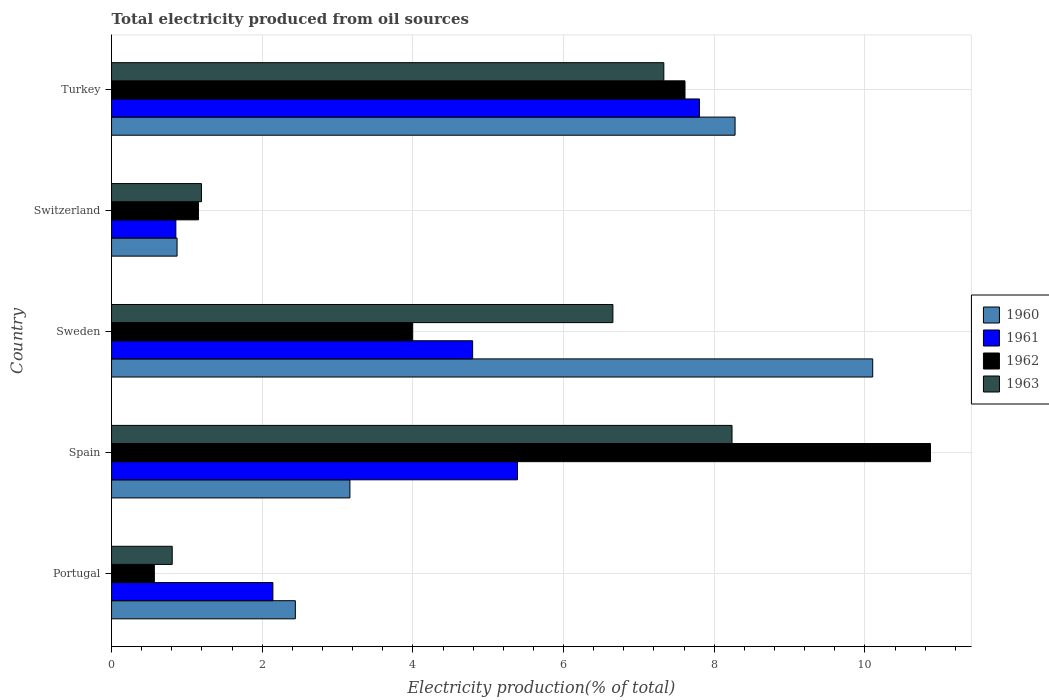How many different coloured bars are there?
Offer a very short reply. 4. Are the number of bars per tick equal to the number of legend labels?
Ensure brevity in your answer.  Yes. Are the number of bars on each tick of the Y-axis equal?
Provide a succinct answer. Yes. What is the label of the 2nd group of bars from the top?
Your response must be concise. Switzerland. In how many cases, is the number of bars for a given country not equal to the number of legend labels?
Provide a succinct answer. 0. What is the total electricity produced in 1961 in Spain?
Keep it short and to the point. 5.39. Across all countries, what is the maximum total electricity produced in 1963?
Your answer should be compact. 8.24. Across all countries, what is the minimum total electricity produced in 1960?
Make the answer very short. 0.87. What is the total total electricity produced in 1961 in the graph?
Your response must be concise. 20.98. What is the difference between the total electricity produced in 1962 in Portugal and that in Spain?
Your answer should be compact. -10.3. What is the difference between the total electricity produced in 1960 in Sweden and the total electricity produced in 1963 in Spain?
Give a very brief answer. 1.87. What is the average total electricity produced in 1962 per country?
Give a very brief answer. 4.84. What is the difference between the total electricity produced in 1963 and total electricity produced in 1960 in Turkey?
Keep it short and to the point. -0.95. What is the ratio of the total electricity produced in 1960 in Spain to that in Turkey?
Provide a succinct answer. 0.38. Is the total electricity produced in 1961 in Portugal less than that in Switzerland?
Make the answer very short. No. What is the difference between the highest and the second highest total electricity produced in 1961?
Your answer should be compact. 2.42. What is the difference between the highest and the lowest total electricity produced in 1961?
Your response must be concise. 6.95. In how many countries, is the total electricity produced in 1960 greater than the average total electricity produced in 1960 taken over all countries?
Your answer should be very brief. 2. What does the 2nd bar from the top in Portugal represents?
Your response must be concise. 1962. What does the 4th bar from the bottom in Portugal represents?
Make the answer very short. 1963. Are all the bars in the graph horizontal?
Ensure brevity in your answer.  Yes. Are the values on the major ticks of X-axis written in scientific E-notation?
Keep it short and to the point. No. Does the graph contain grids?
Offer a very short reply. Yes. What is the title of the graph?
Make the answer very short. Total electricity produced from oil sources. What is the label or title of the X-axis?
Keep it short and to the point. Electricity production(% of total). What is the label or title of the Y-axis?
Offer a terse response. Country. What is the Electricity production(% of total) in 1960 in Portugal?
Ensure brevity in your answer.  2.44. What is the Electricity production(% of total) of 1961 in Portugal?
Give a very brief answer. 2.14. What is the Electricity production(% of total) in 1962 in Portugal?
Your answer should be very brief. 0.57. What is the Electricity production(% of total) in 1963 in Portugal?
Make the answer very short. 0.81. What is the Electricity production(% of total) in 1960 in Spain?
Provide a succinct answer. 3.16. What is the Electricity production(% of total) in 1961 in Spain?
Your response must be concise. 5.39. What is the Electricity production(% of total) of 1962 in Spain?
Offer a terse response. 10.87. What is the Electricity production(% of total) in 1963 in Spain?
Your response must be concise. 8.24. What is the Electricity production(% of total) in 1960 in Sweden?
Keep it short and to the point. 10.1. What is the Electricity production(% of total) of 1961 in Sweden?
Offer a terse response. 4.79. What is the Electricity production(% of total) in 1962 in Sweden?
Provide a succinct answer. 4. What is the Electricity production(% of total) in 1963 in Sweden?
Your response must be concise. 6.66. What is the Electricity production(% of total) of 1960 in Switzerland?
Your response must be concise. 0.87. What is the Electricity production(% of total) of 1961 in Switzerland?
Offer a very short reply. 0.85. What is the Electricity production(% of total) in 1962 in Switzerland?
Make the answer very short. 1.15. What is the Electricity production(% of total) of 1963 in Switzerland?
Keep it short and to the point. 1.19. What is the Electricity production(% of total) in 1960 in Turkey?
Offer a very short reply. 8.28. What is the Electricity production(% of total) in 1961 in Turkey?
Provide a short and direct response. 7.8. What is the Electricity production(% of total) of 1962 in Turkey?
Offer a terse response. 7.61. What is the Electricity production(% of total) in 1963 in Turkey?
Your answer should be compact. 7.33. Across all countries, what is the maximum Electricity production(% of total) in 1960?
Offer a terse response. 10.1. Across all countries, what is the maximum Electricity production(% of total) in 1961?
Your answer should be very brief. 7.8. Across all countries, what is the maximum Electricity production(% of total) of 1962?
Offer a very short reply. 10.87. Across all countries, what is the maximum Electricity production(% of total) of 1963?
Ensure brevity in your answer.  8.24. Across all countries, what is the minimum Electricity production(% of total) in 1960?
Offer a terse response. 0.87. Across all countries, what is the minimum Electricity production(% of total) of 1961?
Keep it short and to the point. 0.85. Across all countries, what is the minimum Electricity production(% of total) of 1962?
Offer a very short reply. 0.57. Across all countries, what is the minimum Electricity production(% of total) in 1963?
Your answer should be compact. 0.81. What is the total Electricity production(% of total) of 1960 in the graph?
Your answer should be very brief. 24.85. What is the total Electricity production(% of total) in 1961 in the graph?
Make the answer very short. 20.98. What is the total Electricity production(% of total) of 1962 in the graph?
Ensure brevity in your answer.  24.2. What is the total Electricity production(% of total) of 1963 in the graph?
Offer a terse response. 24.22. What is the difference between the Electricity production(% of total) in 1960 in Portugal and that in Spain?
Provide a succinct answer. -0.72. What is the difference between the Electricity production(% of total) in 1961 in Portugal and that in Spain?
Ensure brevity in your answer.  -3.25. What is the difference between the Electricity production(% of total) of 1962 in Portugal and that in Spain?
Provide a short and direct response. -10.3. What is the difference between the Electricity production(% of total) in 1963 in Portugal and that in Spain?
Provide a succinct answer. -7.43. What is the difference between the Electricity production(% of total) in 1960 in Portugal and that in Sweden?
Ensure brevity in your answer.  -7.66. What is the difference between the Electricity production(% of total) of 1961 in Portugal and that in Sweden?
Make the answer very short. -2.65. What is the difference between the Electricity production(% of total) in 1962 in Portugal and that in Sweden?
Your response must be concise. -3.43. What is the difference between the Electricity production(% of total) in 1963 in Portugal and that in Sweden?
Ensure brevity in your answer.  -5.85. What is the difference between the Electricity production(% of total) of 1960 in Portugal and that in Switzerland?
Your answer should be very brief. 1.57. What is the difference between the Electricity production(% of total) in 1961 in Portugal and that in Switzerland?
Your answer should be compact. 1.29. What is the difference between the Electricity production(% of total) of 1962 in Portugal and that in Switzerland?
Give a very brief answer. -0.59. What is the difference between the Electricity production(% of total) of 1963 in Portugal and that in Switzerland?
Keep it short and to the point. -0.39. What is the difference between the Electricity production(% of total) in 1960 in Portugal and that in Turkey?
Provide a succinct answer. -5.84. What is the difference between the Electricity production(% of total) in 1961 in Portugal and that in Turkey?
Keep it short and to the point. -5.66. What is the difference between the Electricity production(% of total) in 1962 in Portugal and that in Turkey?
Provide a short and direct response. -7.04. What is the difference between the Electricity production(% of total) in 1963 in Portugal and that in Turkey?
Offer a terse response. -6.53. What is the difference between the Electricity production(% of total) in 1960 in Spain and that in Sweden?
Your response must be concise. -6.94. What is the difference between the Electricity production(% of total) in 1961 in Spain and that in Sweden?
Ensure brevity in your answer.  0.6. What is the difference between the Electricity production(% of total) in 1962 in Spain and that in Sweden?
Give a very brief answer. 6.87. What is the difference between the Electricity production(% of total) of 1963 in Spain and that in Sweden?
Ensure brevity in your answer.  1.58. What is the difference between the Electricity production(% of total) of 1960 in Spain and that in Switzerland?
Offer a terse response. 2.29. What is the difference between the Electricity production(% of total) in 1961 in Spain and that in Switzerland?
Provide a succinct answer. 4.53. What is the difference between the Electricity production(% of total) in 1962 in Spain and that in Switzerland?
Your answer should be compact. 9.72. What is the difference between the Electricity production(% of total) in 1963 in Spain and that in Switzerland?
Give a very brief answer. 7.04. What is the difference between the Electricity production(% of total) of 1960 in Spain and that in Turkey?
Offer a terse response. -5.11. What is the difference between the Electricity production(% of total) of 1961 in Spain and that in Turkey?
Give a very brief answer. -2.42. What is the difference between the Electricity production(% of total) of 1962 in Spain and that in Turkey?
Give a very brief answer. 3.26. What is the difference between the Electricity production(% of total) of 1963 in Spain and that in Turkey?
Ensure brevity in your answer.  0.91. What is the difference between the Electricity production(% of total) of 1960 in Sweden and that in Switzerland?
Provide a succinct answer. 9.23. What is the difference between the Electricity production(% of total) of 1961 in Sweden and that in Switzerland?
Offer a very short reply. 3.94. What is the difference between the Electricity production(% of total) in 1962 in Sweden and that in Switzerland?
Your response must be concise. 2.84. What is the difference between the Electricity production(% of total) in 1963 in Sweden and that in Switzerland?
Your response must be concise. 5.46. What is the difference between the Electricity production(% of total) in 1960 in Sweden and that in Turkey?
Make the answer very short. 1.83. What is the difference between the Electricity production(% of total) in 1961 in Sweden and that in Turkey?
Ensure brevity in your answer.  -3.01. What is the difference between the Electricity production(% of total) in 1962 in Sweden and that in Turkey?
Offer a very short reply. -3.61. What is the difference between the Electricity production(% of total) in 1963 in Sweden and that in Turkey?
Keep it short and to the point. -0.68. What is the difference between the Electricity production(% of total) in 1960 in Switzerland and that in Turkey?
Offer a terse response. -7.41. What is the difference between the Electricity production(% of total) in 1961 in Switzerland and that in Turkey?
Offer a terse response. -6.95. What is the difference between the Electricity production(% of total) in 1962 in Switzerland and that in Turkey?
Ensure brevity in your answer.  -6.46. What is the difference between the Electricity production(% of total) in 1963 in Switzerland and that in Turkey?
Provide a succinct answer. -6.14. What is the difference between the Electricity production(% of total) in 1960 in Portugal and the Electricity production(% of total) in 1961 in Spain?
Provide a succinct answer. -2.95. What is the difference between the Electricity production(% of total) of 1960 in Portugal and the Electricity production(% of total) of 1962 in Spain?
Your answer should be very brief. -8.43. What is the difference between the Electricity production(% of total) in 1960 in Portugal and the Electricity production(% of total) in 1963 in Spain?
Provide a short and direct response. -5.8. What is the difference between the Electricity production(% of total) in 1961 in Portugal and the Electricity production(% of total) in 1962 in Spain?
Offer a very short reply. -8.73. What is the difference between the Electricity production(% of total) in 1961 in Portugal and the Electricity production(% of total) in 1963 in Spain?
Give a very brief answer. -6.09. What is the difference between the Electricity production(% of total) in 1962 in Portugal and the Electricity production(% of total) in 1963 in Spain?
Keep it short and to the point. -7.67. What is the difference between the Electricity production(% of total) in 1960 in Portugal and the Electricity production(% of total) in 1961 in Sweden?
Keep it short and to the point. -2.35. What is the difference between the Electricity production(% of total) of 1960 in Portugal and the Electricity production(% of total) of 1962 in Sweden?
Make the answer very short. -1.56. What is the difference between the Electricity production(% of total) in 1960 in Portugal and the Electricity production(% of total) in 1963 in Sweden?
Provide a short and direct response. -4.22. What is the difference between the Electricity production(% of total) of 1961 in Portugal and the Electricity production(% of total) of 1962 in Sweden?
Offer a very short reply. -1.86. What is the difference between the Electricity production(% of total) of 1961 in Portugal and the Electricity production(% of total) of 1963 in Sweden?
Offer a very short reply. -4.51. What is the difference between the Electricity production(% of total) in 1962 in Portugal and the Electricity production(% of total) in 1963 in Sweden?
Your response must be concise. -6.09. What is the difference between the Electricity production(% of total) in 1960 in Portugal and the Electricity production(% of total) in 1961 in Switzerland?
Make the answer very short. 1.59. What is the difference between the Electricity production(% of total) in 1960 in Portugal and the Electricity production(% of total) in 1962 in Switzerland?
Your answer should be compact. 1.29. What is the difference between the Electricity production(% of total) of 1960 in Portugal and the Electricity production(% of total) of 1963 in Switzerland?
Provide a short and direct response. 1.25. What is the difference between the Electricity production(% of total) in 1961 in Portugal and the Electricity production(% of total) in 1962 in Switzerland?
Make the answer very short. 0.99. What is the difference between the Electricity production(% of total) in 1961 in Portugal and the Electricity production(% of total) in 1963 in Switzerland?
Ensure brevity in your answer.  0.95. What is the difference between the Electricity production(% of total) in 1962 in Portugal and the Electricity production(% of total) in 1963 in Switzerland?
Your response must be concise. -0.63. What is the difference between the Electricity production(% of total) in 1960 in Portugal and the Electricity production(% of total) in 1961 in Turkey?
Keep it short and to the point. -5.36. What is the difference between the Electricity production(% of total) of 1960 in Portugal and the Electricity production(% of total) of 1962 in Turkey?
Offer a terse response. -5.17. What is the difference between the Electricity production(% of total) in 1960 in Portugal and the Electricity production(% of total) in 1963 in Turkey?
Ensure brevity in your answer.  -4.89. What is the difference between the Electricity production(% of total) in 1961 in Portugal and the Electricity production(% of total) in 1962 in Turkey?
Offer a terse response. -5.47. What is the difference between the Electricity production(% of total) in 1961 in Portugal and the Electricity production(% of total) in 1963 in Turkey?
Make the answer very short. -5.19. What is the difference between the Electricity production(% of total) in 1962 in Portugal and the Electricity production(% of total) in 1963 in Turkey?
Ensure brevity in your answer.  -6.76. What is the difference between the Electricity production(% of total) of 1960 in Spain and the Electricity production(% of total) of 1961 in Sweden?
Give a very brief answer. -1.63. What is the difference between the Electricity production(% of total) of 1960 in Spain and the Electricity production(% of total) of 1963 in Sweden?
Provide a short and direct response. -3.49. What is the difference between the Electricity production(% of total) of 1961 in Spain and the Electricity production(% of total) of 1962 in Sweden?
Ensure brevity in your answer.  1.39. What is the difference between the Electricity production(% of total) of 1961 in Spain and the Electricity production(% of total) of 1963 in Sweden?
Your answer should be compact. -1.27. What is the difference between the Electricity production(% of total) in 1962 in Spain and the Electricity production(% of total) in 1963 in Sweden?
Provide a short and direct response. 4.22. What is the difference between the Electricity production(% of total) of 1960 in Spain and the Electricity production(% of total) of 1961 in Switzerland?
Offer a terse response. 2.31. What is the difference between the Electricity production(% of total) of 1960 in Spain and the Electricity production(% of total) of 1962 in Switzerland?
Provide a succinct answer. 2.01. What is the difference between the Electricity production(% of total) in 1960 in Spain and the Electricity production(% of total) in 1963 in Switzerland?
Your answer should be compact. 1.97. What is the difference between the Electricity production(% of total) in 1961 in Spain and the Electricity production(% of total) in 1962 in Switzerland?
Give a very brief answer. 4.24. What is the difference between the Electricity production(% of total) of 1961 in Spain and the Electricity production(% of total) of 1963 in Switzerland?
Your response must be concise. 4.2. What is the difference between the Electricity production(% of total) in 1962 in Spain and the Electricity production(% of total) in 1963 in Switzerland?
Your answer should be compact. 9.68. What is the difference between the Electricity production(% of total) in 1960 in Spain and the Electricity production(% of total) in 1961 in Turkey?
Your answer should be very brief. -4.64. What is the difference between the Electricity production(% of total) of 1960 in Spain and the Electricity production(% of total) of 1962 in Turkey?
Make the answer very short. -4.45. What is the difference between the Electricity production(% of total) of 1960 in Spain and the Electricity production(% of total) of 1963 in Turkey?
Offer a terse response. -4.17. What is the difference between the Electricity production(% of total) in 1961 in Spain and the Electricity production(% of total) in 1962 in Turkey?
Your answer should be very brief. -2.22. What is the difference between the Electricity production(% of total) in 1961 in Spain and the Electricity production(% of total) in 1963 in Turkey?
Your response must be concise. -1.94. What is the difference between the Electricity production(% of total) in 1962 in Spain and the Electricity production(% of total) in 1963 in Turkey?
Offer a terse response. 3.54. What is the difference between the Electricity production(% of total) in 1960 in Sweden and the Electricity production(% of total) in 1961 in Switzerland?
Provide a succinct answer. 9.25. What is the difference between the Electricity production(% of total) in 1960 in Sweden and the Electricity production(% of total) in 1962 in Switzerland?
Offer a terse response. 8.95. What is the difference between the Electricity production(% of total) in 1960 in Sweden and the Electricity production(% of total) in 1963 in Switzerland?
Ensure brevity in your answer.  8.91. What is the difference between the Electricity production(% of total) of 1961 in Sweden and the Electricity production(% of total) of 1962 in Switzerland?
Provide a succinct answer. 3.64. What is the difference between the Electricity production(% of total) in 1961 in Sweden and the Electricity production(% of total) in 1963 in Switzerland?
Your answer should be compact. 3.6. What is the difference between the Electricity production(% of total) in 1962 in Sweden and the Electricity production(% of total) in 1963 in Switzerland?
Provide a succinct answer. 2.8. What is the difference between the Electricity production(% of total) of 1960 in Sweden and the Electricity production(% of total) of 1961 in Turkey?
Give a very brief answer. 2.3. What is the difference between the Electricity production(% of total) in 1960 in Sweden and the Electricity production(% of total) in 1962 in Turkey?
Make the answer very short. 2.49. What is the difference between the Electricity production(% of total) in 1960 in Sweden and the Electricity production(% of total) in 1963 in Turkey?
Ensure brevity in your answer.  2.77. What is the difference between the Electricity production(% of total) in 1961 in Sweden and the Electricity production(% of total) in 1962 in Turkey?
Keep it short and to the point. -2.82. What is the difference between the Electricity production(% of total) of 1961 in Sweden and the Electricity production(% of total) of 1963 in Turkey?
Your answer should be very brief. -2.54. What is the difference between the Electricity production(% of total) in 1962 in Sweden and the Electricity production(% of total) in 1963 in Turkey?
Provide a succinct answer. -3.33. What is the difference between the Electricity production(% of total) in 1960 in Switzerland and the Electricity production(% of total) in 1961 in Turkey?
Give a very brief answer. -6.94. What is the difference between the Electricity production(% of total) of 1960 in Switzerland and the Electricity production(% of total) of 1962 in Turkey?
Provide a succinct answer. -6.74. What is the difference between the Electricity production(% of total) in 1960 in Switzerland and the Electricity production(% of total) in 1963 in Turkey?
Your answer should be very brief. -6.46. What is the difference between the Electricity production(% of total) in 1961 in Switzerland and the Electricity production(% of total) in 1962 in Turkey?
Give a very brief answer. -6.76. What is the difference between the Electricity production(% of total) in 1961 in Switzerland and the Electricity production(% of total) in 1963 in Turkey?
Offer a very short reply. -6.48. What is the difference between the Electricity production(% of total) of 1962 in Switzerland and the Electricity production(% of total) of 1963 in Turkey?
Give a very brief answer. -6.18. What is the average Electricity production(% of total) in 1960 per country?
Your response must be concise. 4.97. What is the average Electricity production(% of total) of 1961 per country?
Your response must be concise. 4.2. What is the average Electricity production(% of total) of 1962 per country?
Provide a succinct answer. 4.84. What is the average Electricity production(% of total) in 1963 per country?
Offer a terse response. 4.84. What is the difference between the Electricity production(% of total) of 1960 and Electricity production(% of total) of 1961 in Portugal?
Offer a very short reply. 0.3. What is the difference between the Electricity production(% of total) in 1960 and Electricity production(% of total) in 1962 in Portugal?
Offer a very short reply. 1.87. What is the difference between the Electricity production(% of total) in 1960 and Electricity production(% of total) in 1963 in Portugal?
Offer a terse response. 1.63. What is the difference between the Electricity production(% of total) of 1961 and Electricity production(% of total) of 1962 in Portugal?
Provide a short and direct response. 1.57. What is the difference between the Electricity production(% of total) in 1961 and Electricity production(% of total) in 1963 in Portugal?
Offer a terse response. 1.34. What is the difference between the Electricity production(% of total) of 1962 and Electricity production(% of total) of 1963 in Portugal?
Offer a terse response. -0.24. What is the difference between the Electricity production(% of total) in 1960 and Electricity production(% of total) in 1961 in Spain?
Ensure brevity in your answer.  -2.22. What is the difference between the Electricity production(% of total) in 1960 and Electricity production(% of total) in 1962 in Spain?
Give a very brief answer. -7.71. What is the difference between the Electricity production(% of total) in 1960 and Electricity production(% of total) in 1963 in Spain?
Provide a succinct answer. -5.07. What is the difference between the Electricity production(% of total) in 1961 and Electricity production(% of total) in 1962 in Spain?
Keep it short and to the point. -5.48. What is the difference between the Electricity production(% of total) in 1961 and Electricity production(% of total) in 1963 in Spain?
Your response must be concise. -2.85. What is the difference between the Electricity production(% of total) in 1962 and Electricity production(% of total) in 1963 in Spain?
Keep it short and to the point. 2.63. What is the difference between the Electricity production(% of total) of 1960 and Electricity production(% of total) of 1961 in Sweden?
Keep it short and to the point. 5.31. What is the difference between the Electricity production(% of total) in 1960 and Electricity production(% of total) in 1962 in Sweden?
Offer a very short reply. 6.11. What is the difference between the Electricity production(% of total) of 1960 and Electricity production(% of total) of 1963 in Sweden?
Offer a terse response. 3.45. What is the difference between the Electricity production(% of total) in 1961 and Electricity production(% of total) in 1962 in Sweden?
Make the answer very short. 0.8. What is the difference between the Electricity production(% of total) in 1961 and Electricity production(% of total) in 1963 in Sweden?
Offer a terse response. -1.86. What is the difference between the Electricity production(% of total) of 1962 and Electricity production(% of total) of 1963 in Sweden?
Make the answer very short. -2.66. What is the difference between the Electricity production(% of total) of 1960 and Electricity production(% of total) of 1961 in Switzerland?
Your response must be concise. 0.02. What is the difference between the Electricity production(% of total) of 1960 and Electricity production(% of total) of 1962 in Switzerland?
Your response must be concise. -0.28. What is the difference between the Electricity production(% of total) of 1960 and Electricity production(% of total) of 1963 in Switzerland?
Give a very brief answer. -0.32. What is the difference between the Electricity production(% of total) of 1961 and Electricity production(% of total) of 1962 in Switzerland?
Provide a short and direct response. -0.3. What is the difference between the Electricity production(% of total) in 1961 and Electricity production(% of total) in 1963 in Switzerland?
Give a very brief answer. -0.34. What is the difference between the Electricity production(% of total) of 1962 and Electricity production(% of total) of 1963 in Switzerland?
Your answer should be very brief. -0.04. What is the difference between the Electricity production(% of total) in 1960 and Electricity production(% of total) in 1961 in Turkey?
Your answer should be compact. 0.47. What is the difference between the Electricity production(% of total) in 1960 and Electricity production(% of total) in 1962 in Turkey?
Provide a succinct answer. 0.66. What is the difference between the Electricity production(% of total) in 1960 and Electricity production(% of total) in 1963 in Turkey?
Provide a short and direct response. 0.95. What is the difference between the Electricity production(% of total) of 1961 and Electricity production(% of total) of 1962 in Turkey?
Make the answer very short. 0.19. What is the difference between the Electricity production(% of total) of 1961 and Electricity production(% of total) of 1963 in Turkey?
Your answer should be compact. 0.47. What is the difference between the Electricity production(% of total) in 1962 and Electricity production(% of total) in 1963 in Turkey?
Offer a very short reply. 0.28. What is the ratio of the Electricity production(% of total) of 1960 in Portugal to that in Spain?
Give a very brief answer. 0.77. What is the ratio of the Electricity production(% of total) in 1961 in Portugal to that in Spain?
Your answer should be compact. 0.4. What is the ratio of the Electricity production(% of total) in 1962 in Portugal to that in Spain?
Provide a succinct answer. 0.05. What is the ratio of the Electricity production(% of total) of 1963 in Portugal to that in Spain?
Offer a very short reply. 0.1. What is the ratio of the Electricity production(% of total) of 1960 in Portugal to that in Sweden?
Offer a very short reply. 0.24. What is the ratio of the Electricity production(% of total) of 1961 in Portugal to that in Sweden?
Make the answer very short. 0.45. What is the ratio of the Electricity production(% of total) in 1962 in Portugal to that in Sweden?
Your answer should be compact. 0.14. What is the ratio of the Electricity production(% of total) of 1963 in Portugal to that in Sweden?
Your answer should be very brief. 0.12. What is the ratio of the Electricity production(% of total) of 1960 in Portugal to that in Switzerland?
Give a very brief answer. 2.81. What is the ratio of the Electricity production(% of total) in 1961 in Portugal to that in Switzerland?
Provide a succinct answer. 2.51. What is the ratio of the Electricity production(% of total) in 1962 in Portugal to that in Switzerland?
Provide a short and direct response. 0.49. What is the ratio of the Electricity production(% of total) in 1963 in Portugal to that in Switzerland?
Provide a succinct answer. 0.67. What is the ratio of the Electricity production(% of total) of 1960 in Portugal to that in Turkey?
Provide a succinct answer. 0.29. What is the ratio of the Electricity production(% of total) of 1961 in Portugal to that in Turkey?
Offer a very short reply. 0.27. What is the ratio of the Electricity production(% of total) in 1962 in Portugal to that in Turkey?
Provide a short and direct response. 0.07. What is the ratio of the Electricity production(% of total) in 1963 in Portugal to that in Turkey?
Offer a terse response. 0.11. What is the ratio of the Electricity production(% of total) of 1960 in Spain to that in Sweden?
Offer a very short reply. 0.31. What is the ratio of the Electricity production(% of total) of 1961 in Spain to that in Sweden?
Offer a very short reply. 1.12. What is the ratio of the Electricity production(% of total) in 1962 in Spain to that in Sweden?
Provide a short and direct response. 2.72. What is the ratio of the Electricity production(% of total) in 1963 in Spain to that in Sweden?
Ensure brevity in your answer.  1.24. What is the ratio of the Electricity production(% of total) of 1960 in Spain to that in Switzerland?
Your answer should be very brief. 3.64. What is the ratio of the Electricity production(% of total) of 1961 in Spain to that in Switzerland?
Your answer should be compact. 6.31. What is the ratio of the Electricity production(% of total) in 1962 in Spain to that in Switzerland?
Offer a terse response. 9.43. What is the ratio of the Electricity production(% of total) in 1963 in Spain to that in Switzerland?
Provide a short and direct response. 6.9. What is the ratio of the Electricity production(% of total) in 1960 in Spain to that in Turkey?
Offer a terse response. 0.38. What is the ratio of the Electricity production(% of total) of 1961 in Spain to that in Turkey?
Your answer should be compact. 0.69. What is the ratio of the Electricity production(% of total) of 1962 in Spain to that in Turkey?
Offer a very short reply. 1.43. What is the ratio of the Electricity production(% of total) in 1963 in Spain to that in Turkey?
Ensure brevity in your answer.  1.12. What is the ratio of the Electricity production(% of total) of 1960 in Sweden to that in Switzerland?
Your response must be concise. 11.62. What is the ratio of the Electricity production(% of total) of 1961 in Sweden to that in Switzerland?
Your answer should be very brief. 5.62. What is the ratio of the Electricity production(% of total) in 1962 in Sweden to that in Switzerland?
Offer a terse response. 3.47. What is the ratio of the Electricity production(% of total) in 1963 in Sweden to that in Switzerland?
Provide a succinct answer. 5.58. What is the ratio of the Electricity production(% of total) of 1960 in Sweden to that in Turkey?
Your response must be concise. 1.22. What is the ratio of the Electricity production(% of total) of 1961 in Sweden to that in Turkey?
Offer a terse response. 0.61. What is the ratio of the Electricity production(% of total) of 1962 in Sweden to that in Turkey?
Make the answer very short. 0.53. What is the ratio of the Electricity production(% of total) in 1963 in Sweden to that in Turkey?
Provide a succinct answer. 0.91. What is the ratio of the Electricity production(% of total) in 1960 in Switzerland to that in Turkey?
Your response must be concise. 0.11. What is the ratio of the Electricity production(% of total) in 1961 in Switzerland to that in Turkey?
Your response must be concise. 0.11. What is the ratio of the Electricity production(% of total) of 1962 in Switzerland to that in Turkey?
Make the answer very short. 0.15. What is the ratio of the Electricity production(% of total) of 1963 in Switzerland to that in Turkey?
Your response must be concise. 0.16. What is the difference between the highest and the second highest Electricity production(% of total) of 1960?
Offer a very short reply. 1.83. What is the difference between the highest and the second highest Electricity production(% of total) in 1961?
Keep it short and to the point. 2.42. What is the difference between the highest and the second highest Electricity production(% of total) of 1962?
Offer a terse response. 3.26. What is the difference between the highest and the second highest Electricity production(% of total) of 1963?
Provide a succinct answer. 0.91. What is the difference between the highest and the lowest Electricity production(% of total) in 1960?
Offer a terse response. 9.23. What is the difference between the highest and the lowest Electricity production(% of total) of 1961?
Provide a short and direct response. 6.95. What is the difference between the highest and the lowest Electricity production(% of total) of 1962?
Your response must be concise. 10.3. What is the difference between the highest and the lowest Electricity production(% of total) of 1963?
Provide a succinct answer. 7.43. 